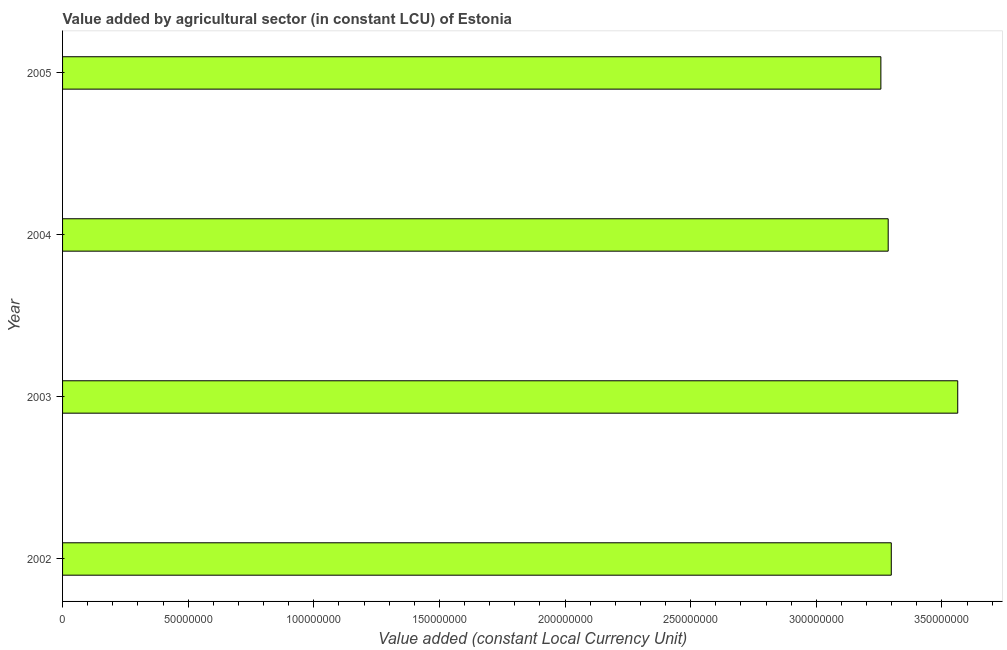Does the graph contain any zero values?
Provide a succinct answer. No. What is the title of the graph?
Your response must be concise. Value added by agricultural sector (in constant LCU) of Estonia. What is the label or title of the X-axis?
Offer a terse response. Value added (constant Local Currency Unit). What is the value added by agriculture sector in 2003?
Your answer should be compact. 3.56e+08. Across all years, what is the maximum value added by agriculture sector?
Your answer should be very brief. 3.56e+08. Across all years, what is the minimum value added by agriculture sector?
Ensure brevity in your answer.  3.26e+08. In which year was the value added by agriculture sector maximum?
Your answer should be very brief. 2003. In which year was the value added by agriculture sector minimum?
Your answer should be compact. 2005. What is the sum of the value added by agriculture sector?
Your answer should be compact. 1.34e+09. What is the difference between the value added by agriculture sector in 2003 and 2004?
Your answer should be very brief. 2.77e+07. What is the average value added by agriculture sector per year?
Provide a succinct answer. 3.35e+08. What is the median value added by agriculture sector?
Your answer should be compact. 3.29e+08. In how many years, is the value added by agriculture sector greater than 130000000 LCU?
Your answer should be very brief. 4. What is the ratio of the value added by agriculture sector in 2002 to that in 2004?
Ensure brevity in your answer.  1. Is the value added by agriculture sector in 2002 less than that in 2005?
Ensure brevity in your answer.  No. What is the difference between the highest and the second highest value added by agriculture sector?
Offer a terse response. 2.64e+07. Is the sum of the value added by agriculture sector in 2003 and 2004 greater than the maximum value added by agriculture sector across all years?
Give a very brief answer. Yes. What is the difference between the highest and the lowest value added by agriculture sector?
Offer a terse response. 3.06e+07. In how many years, is the value added by agriculture sector greater than the average value added by agriculture sector taken over all years?
Offer a terse response. 1. How many years are there in the graph?
Your answer should be very brief. 4. Are the values on the major ticks of X-axis written in scientific E-notation?
Your answer should be compact. No. What is the Value added (constant Local Currency Unit) of 2002?
Provide a short and direct response. 3.30e+08. What is the Value added (constant Local Currency Unit) of 2003?
Provide a short and direct response. 3.56e+08. What is the Value added (constant Local Currency Unit) in 2004?
Provide a succinct answer. 3.29e+08. What is the Value added (constant Local Currency Unit) in 2005?
Offer a very short reply. 3.26e+08. What is the difference between the Value added (constant Local Currency Unit) in 2002 and 2003?
Keep it short and to the point. -2.64e+07. What is the difference between the Value added (constant Local Currency Unit) in 2002 and 2004?
Your response must be concise. 1.23e+06. What is the difference between the Value added (constant Local Currency Unit) in 2002 and 2005?
Ensure brevity in your answer.  4.14e+06. What is the difference between the Value added (constant Local Currency Unit) in 2003 and 2004?
Your answer should be very brief. 2.77e+07. What is the difference between the Value added (constant Local Currency Unit) in 2003 and 2005?
Offer a terse response. 3.06e+07. What is the difference between the Value added (constant Local Currency Unit) in 2004 and 2005?
Your response must be concise. 2.91e+06. What is the ratio of the Value added (constant Local Currency Unit) in 2002 to that in 2003?
Keep it short and to the point. 0.93. What is the ratio of the Value added (constant Local Currency Unit) in 2002 to that in 2004?
Offer a very short reply. 1. What is the ratio of the Value added (constant Local Currency Unit) in 2003 to that in 2004?
Provide a short and direct response. 1.08. What is the ratio of the Value added (constant Local Currency Unit) in 2003 to that in 2005?
Make the answer very short. 1.09. What is the ratio of the Value added (constant Local Currency Unit) in 2004 to that in 2005?
Provide a short and direct response. 1.01. 